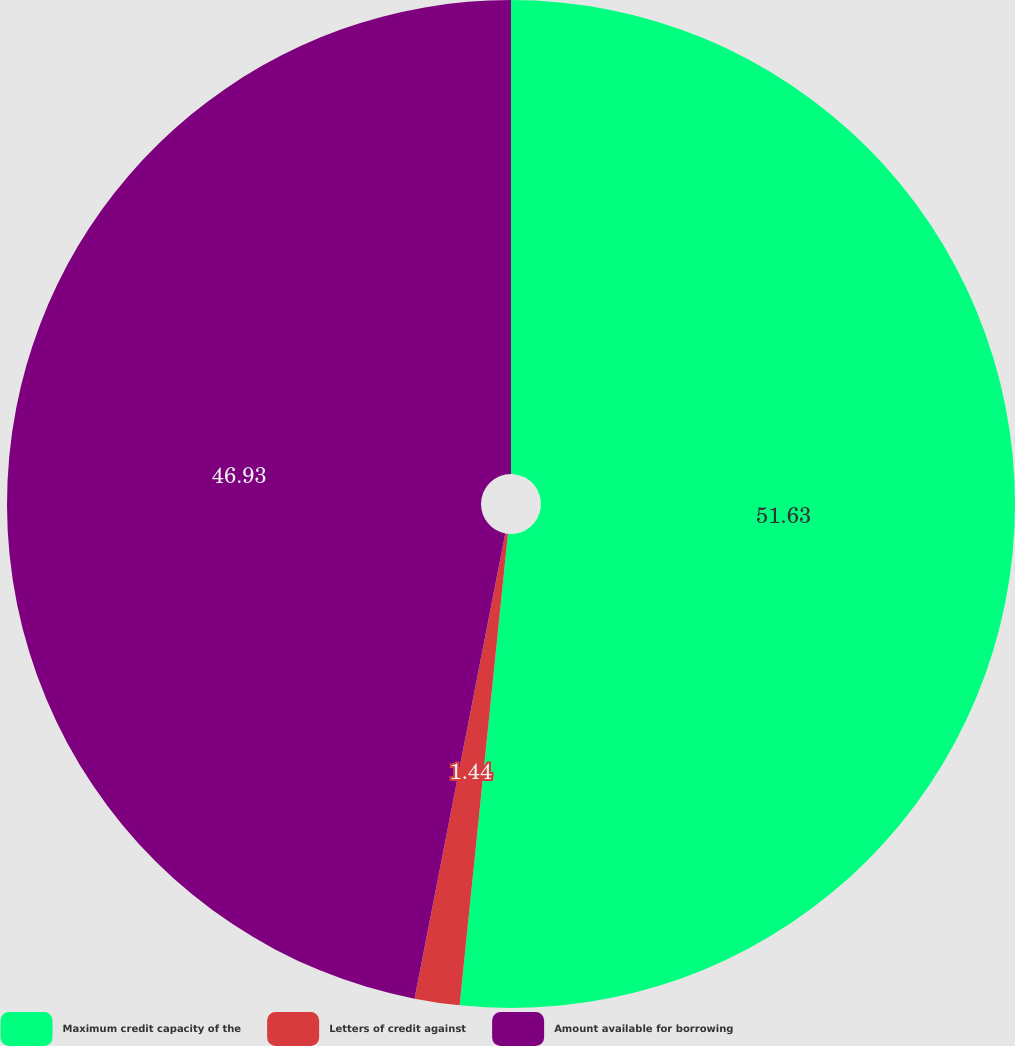Convert chart. <chart><loc_0><loc_0><loc_500><loc_500><pie_chart><fcel>Maximum credit capacity of the<fcel>Letters of credit against<fcel>Amount available for borrowing<nl><fcel>51.62%<fcel>1.44%<fcel>46.93%<nl></chart> 